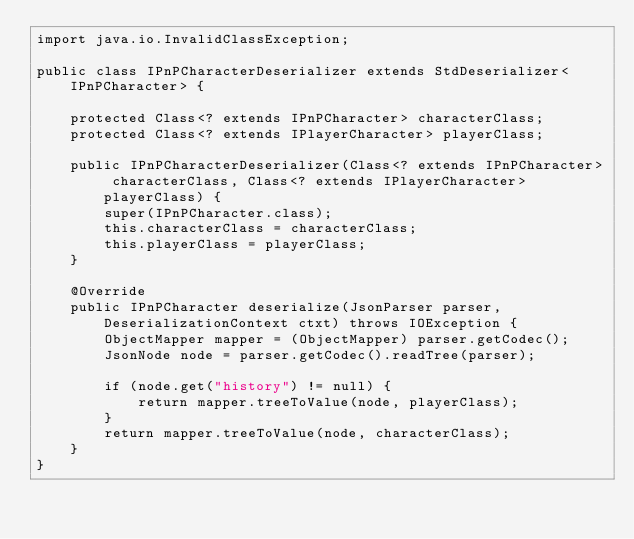Convert code to text. <code><loc_0><loc_0><loc_500><loc_500><_Java_>import java.io.InvalidClassException;

public class IPnPCharacterDeserializer extends StdDeserializer<IPnPCharacter> {

    protected Class<? extends IPnPCharacter> characterClass;
    protected Class<? extends IPlayerCharacter> playerClass;

    public IPnPCharacterDeserializer(Class<? extends IPnPCharacter> characterClass, Class<? extends IPlayerCharacter> playerClass) {
        super(IPnPCharacter.class);
        this.characterClass = characterClass;
        this.playerClass = playerClass;
    }

    @Override
    public IPnPCharacter deserialize(JsonParser parser, DeserializationContext ctxt) throws IOException {
        ObjectMapper mapper = (ObjectMapper) parser.getCodec();
        JsonNode node = parser.getCodec().readTree(parser);

        if (node.get("history") != null) {
            return mapper.treeToValue(node, playerClass);
        }
        return mapper.treeToValue(node, characterClass);
    }
}</code> 